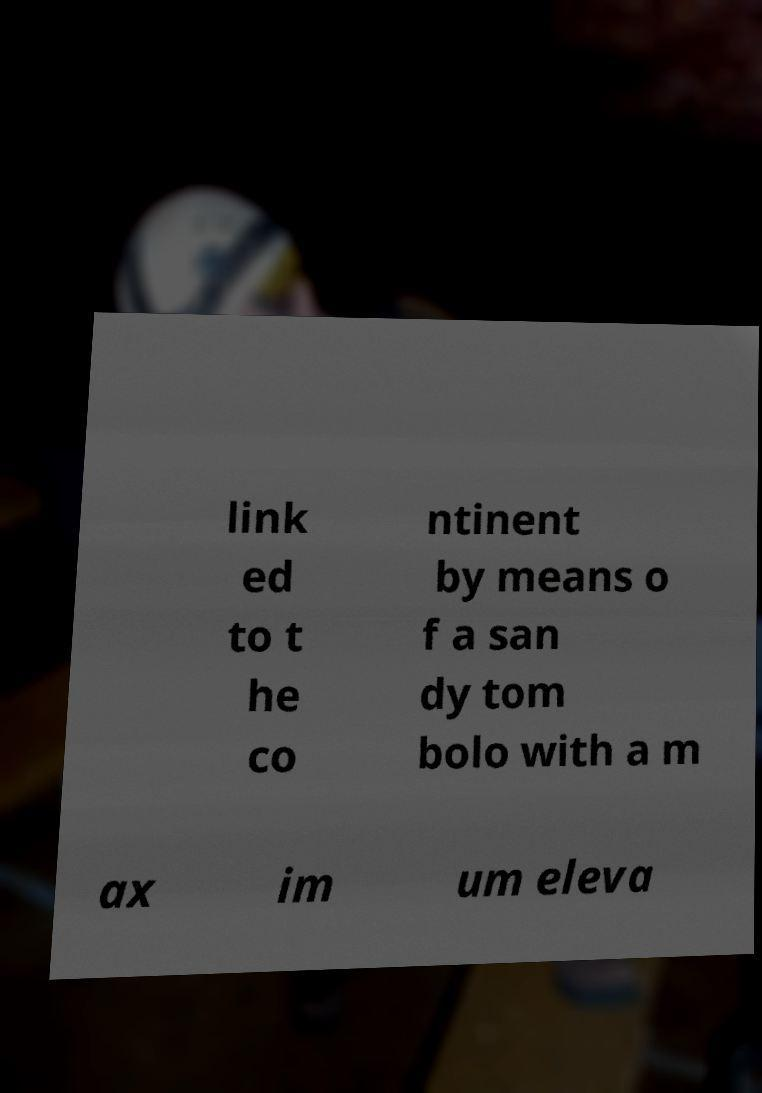Could you extract and type out the text from this image? link ed to t he co ntinent by means o f a san dy tom bolo with a m ax im um eleva 